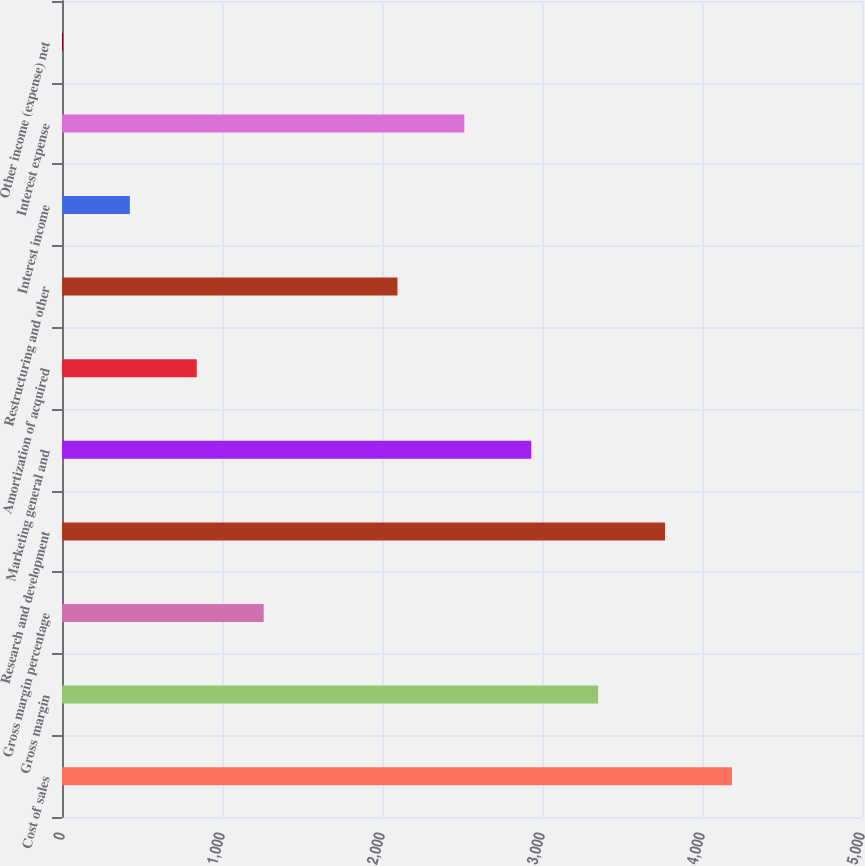<chart> <loc_0><loc_0><loc_500><loc_500><bar_chart><fcel>Cost of sales<fcel>Gross margin<fcel>Gross margin percentage<fcel>Research and development<fcel>Marketing general and<fcel>Amortization of acquired<fcel>Restructuring and other<fcel>Interest income<fcel>Interest expense<fcel>Other income (expense) net<nl><fcel>4187<fcel>3350.8<fcel>1260.3<fcel>3768.9<fcel>2932.7<fcel>842.2<fcel>2096.5<fcel>424.1<fcel>2514.6<fcel>6<nl></chart> 